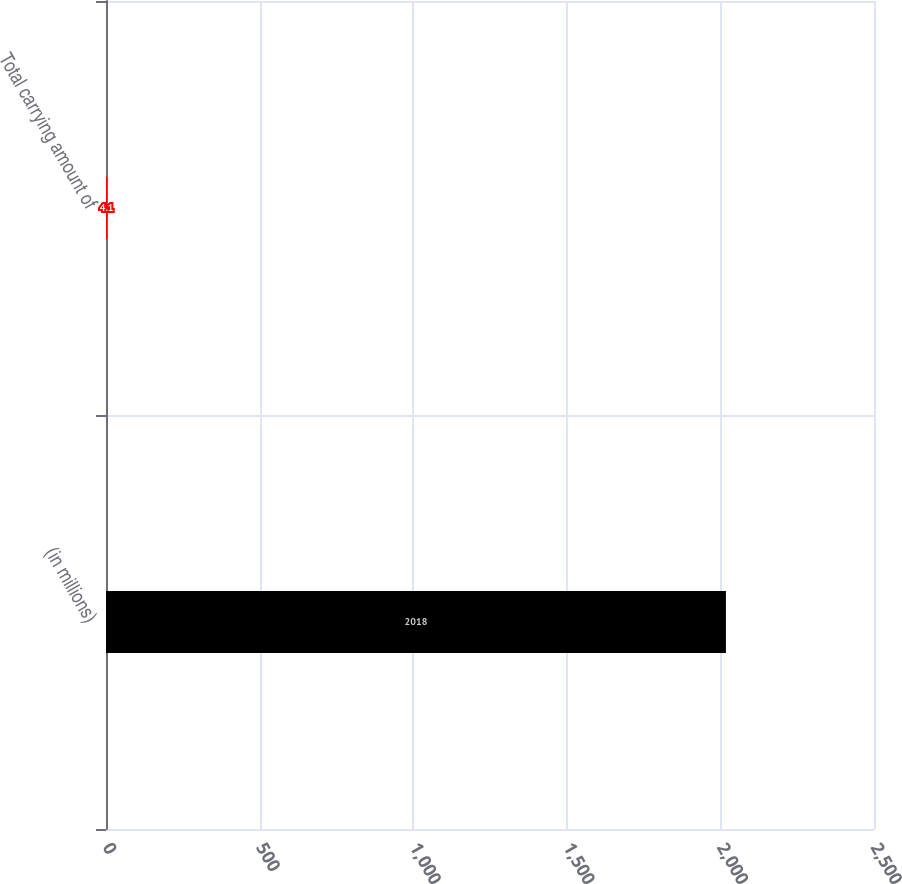Convert chart. <chart><loc_0><loc_0><loc_500><loc_500><bar_chart><fcel>(in millions)<fcel>Total carrying amount of<nl><fcel>2018<fcel>4.1<nl></chart> 